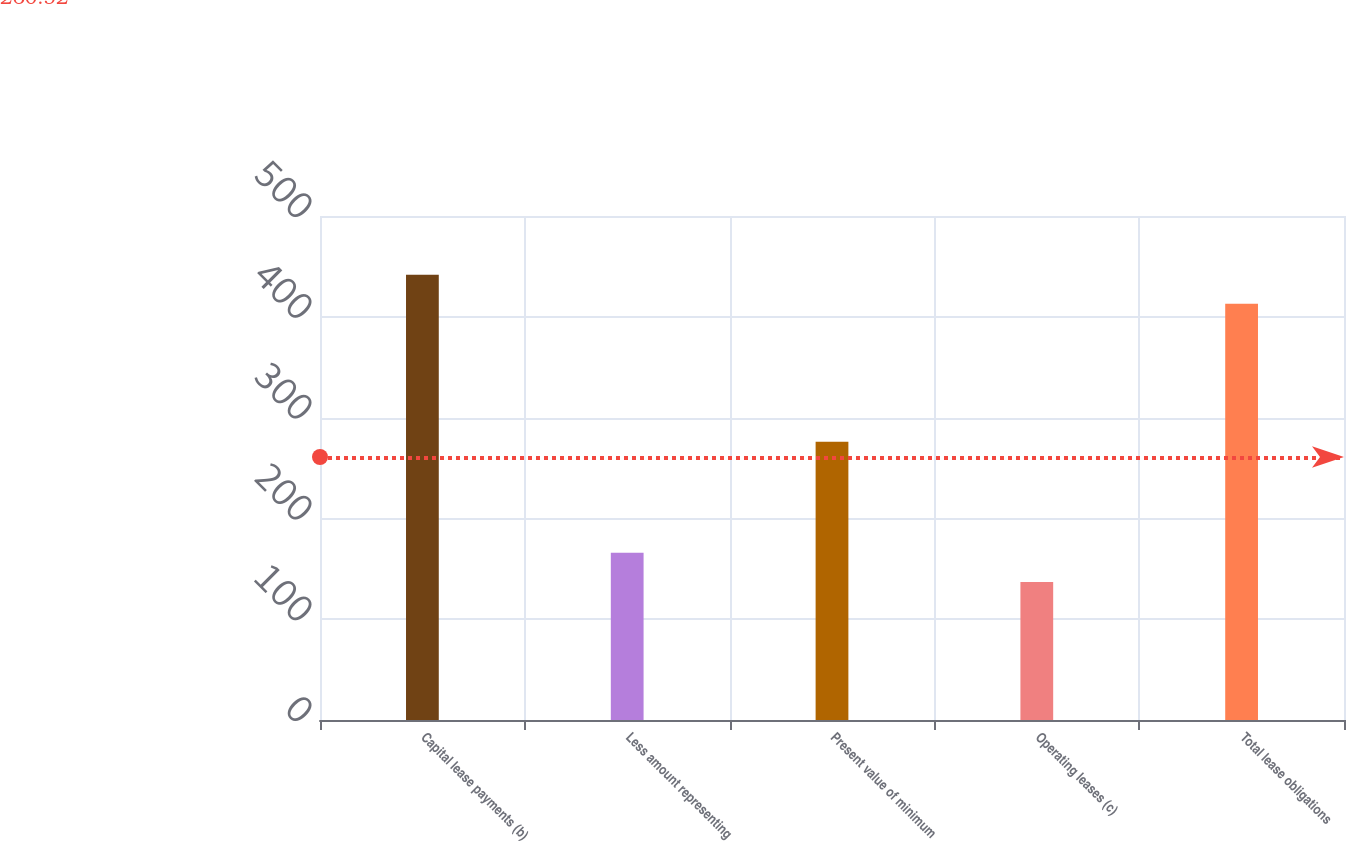<chart> <loc_0><loc_0><loc_500><loc_500><bar_chart><fcel>Capital lease payments (b)<fcel>Less amount representing<fcel>Present value of minimum<fcel>Operating leases (c)<fcel>Total lease obligations<nl><fcel>441.8<fcel>165.8<fcel>276<fcel>137<fcel>413<nl></chart> 